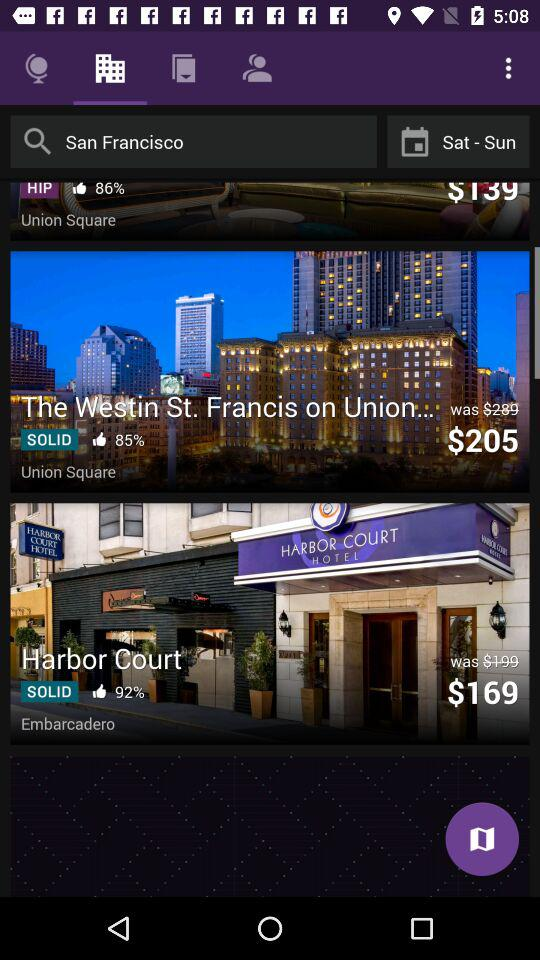What is the percentage of likes for "Harbor Court"? The percentage of likes is 92. 